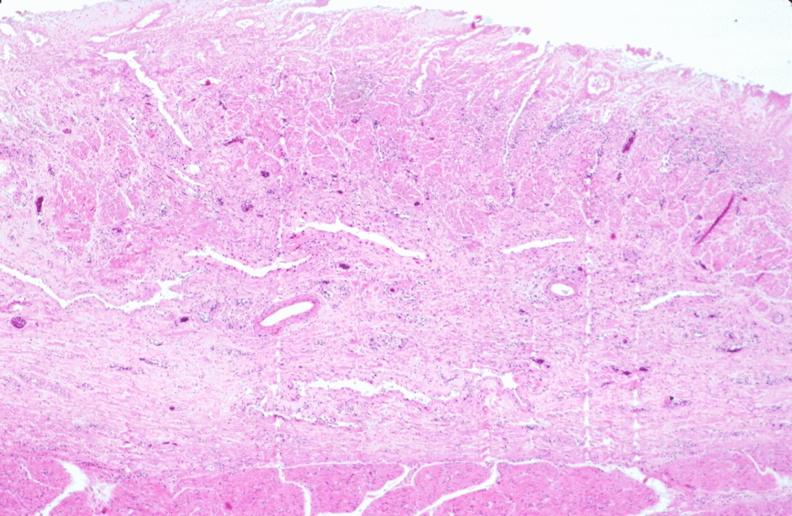does retroperitoneum show stomach, necrotizing esophagitis and gastritis, sulfuric acid ingested as suicide attempt?
Answer the question using a single word or phrase. No 